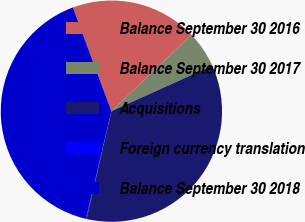Convert chart to OTSL. <chart><loc_0><loc_0><loc_500><loc_500><pie_chart><fcel>Balance September 30 2016<fcel>Balance September 30 2017<fcel>Acquisitions<fcel>Foreign currency translation<fcel>Balance September 30 2018<nl><fcel>18.53%<fcel>5.39%<fcel>35.35%<fcel>0.09%<fcel>40.64%<nl></chart> 